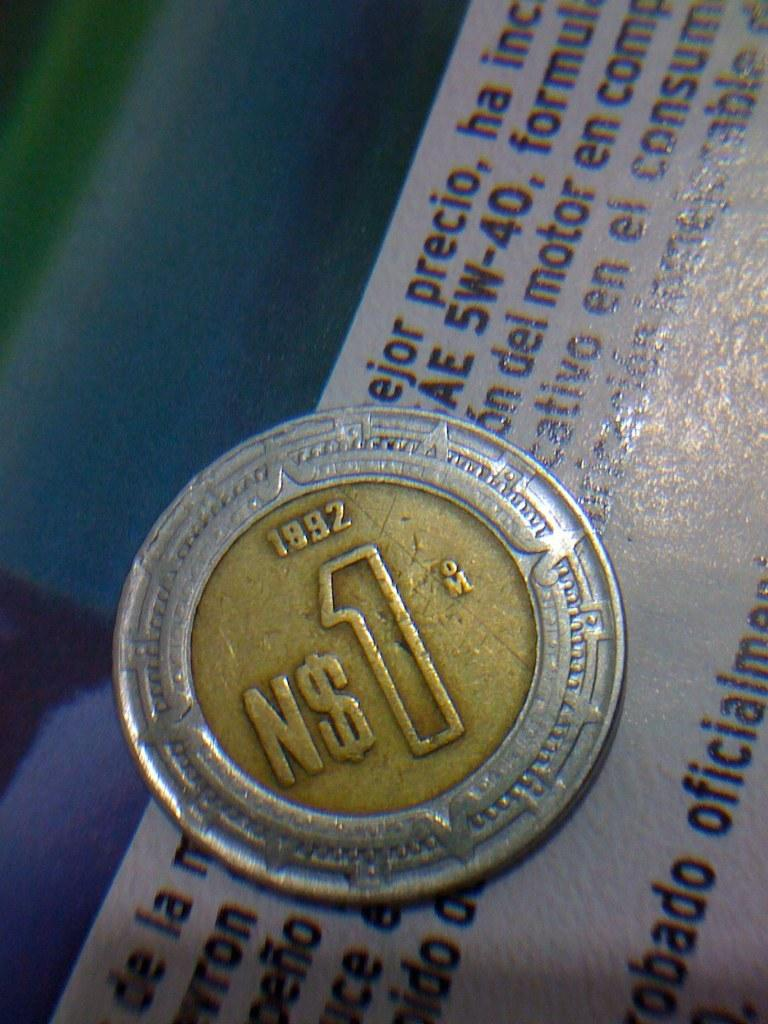<image>
Write a terse but informative summary of the picture. A silver and gold coin from 1892 that is valued at $1. 